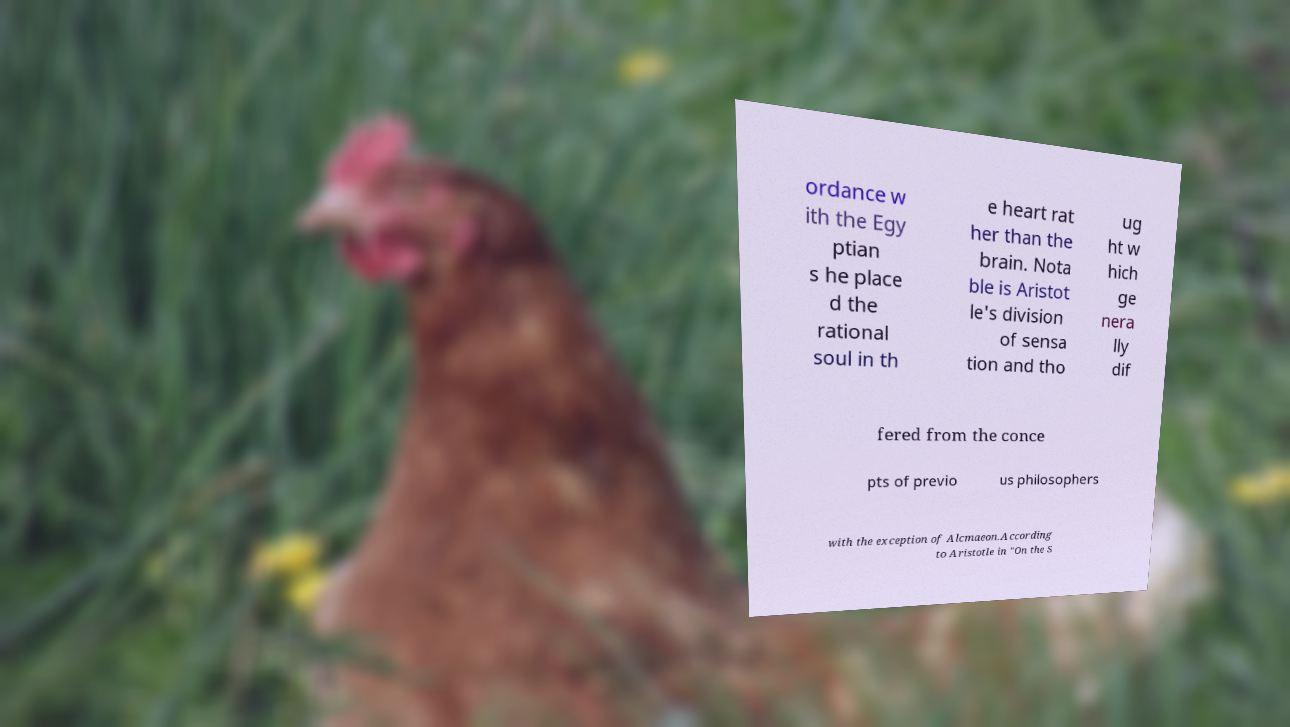Can you accurately transcribe the text from the provided image for me? ordance w ith the Egy ptian s he place d the rational soul in th e heart rat her than the brain. Nota ble is Aristot le's division of sensa tion and tho ug ht w hich ge nera lly dif fered from the conce pts of previo us philosophers with the exception of Alcmaeon.According to Aristotle in "On the S 